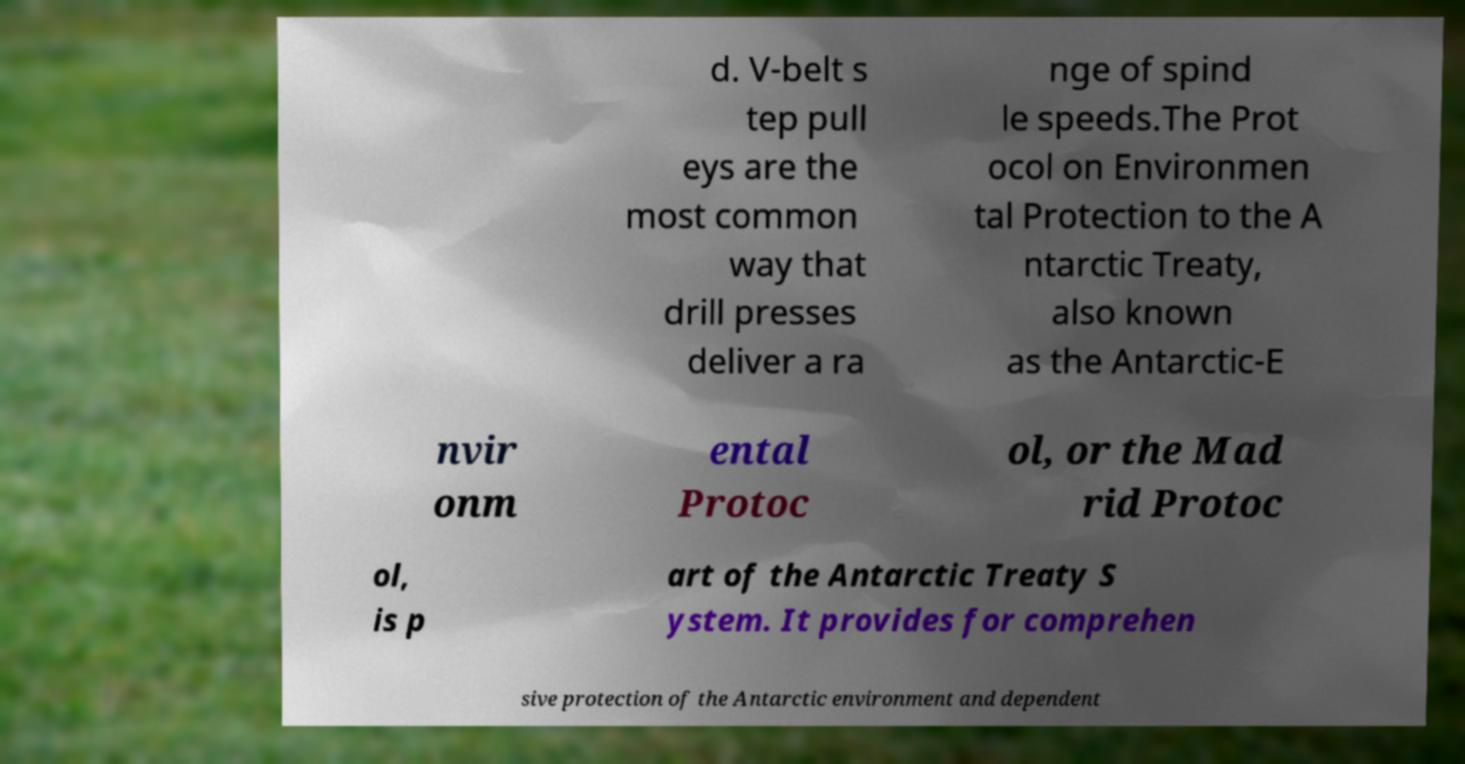Can you read and provide the text displayed in the image?This photo seems to have some interesting text. Can you extract and type it out for me? d. V-belt s tep pull eys are the most common way that drill presses deliver a ra nge of spind le speeds.The Prot ocol on Environmen tal Protection to the A ntarctic Treaty, also known as the Antarctic-E nvir onm ental Protoc ol, or the Mad rid Protoc ol, is p art of the Antarctic Treaty S ystem. It provides for comprehen sive protection of the Antarctic environment and dependent 